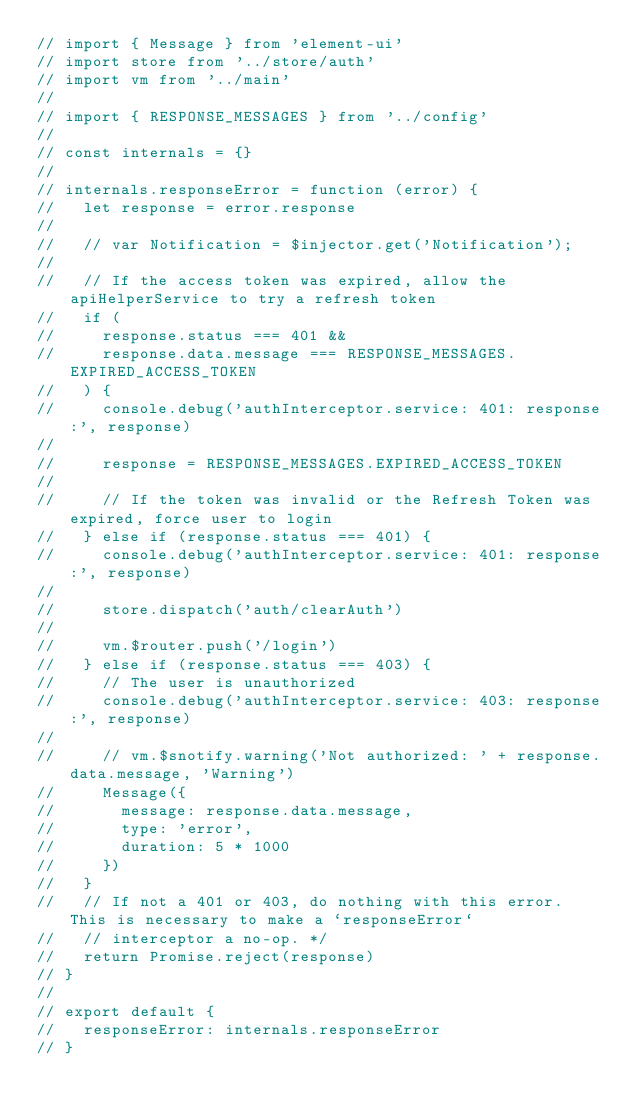Convert code to text. <code><loc_0><loc_0><loc_500><loc_500><_JavaScript_>// import { Message } from 'element-ui'
// import store from '../store/auth'
// import vm from '../main'
//
// import { RESPONSE_MESSAGES } from '../config'
//
// const internals = {}
//
// internals.responseError = function (error) {
//   let response = error.response
//
//   // var Notification = $injector.get('Notification');
//
//   // If the access token was expired, allow the apiHelperService to try a refresh token
//   if (
//     response.status === 401 &&
//     response.data.message === RESPONSE_MESSAGES.EXPIRED_ACCESS_TOKEN
//   ) {
//     console.debug('authInterceptor.service: 401: response:', response)
//
//     response = RESPONSE_MESSAGES.EXPIRED_ACCESS_TOKEN
//
//     // If the token was invalid or the Refresh Token was expired, force user to login
//   } else if (response.status === 401) {
//     console.debug('authInterceptor.service: 401: response:', response)
//
//     store.dispatch('auth/clearAuth')
//
//     vm.$router.push('/login')
//   } else if (response.status === 403) {
//     // The user is unauthorized
//     console.debug('authInterceptor.service: 403: response:', response)
//
//     // vm.$snotify.warning('Not authorized: ' + response.data.message, 'Warning')
//     Message({
//       message: response.data.message,
//       type: 'error',
//       duration: 5 * 1000
//     })
//   }
//   // If not a 401 or 403, do nothing with this error. This is necessary to make a `responseError`
//   // interceptor a no-op. */
//   return Promise.reject(response)
// }
//
// export default {
//   responseError: internals.responseError
// }
</code> 